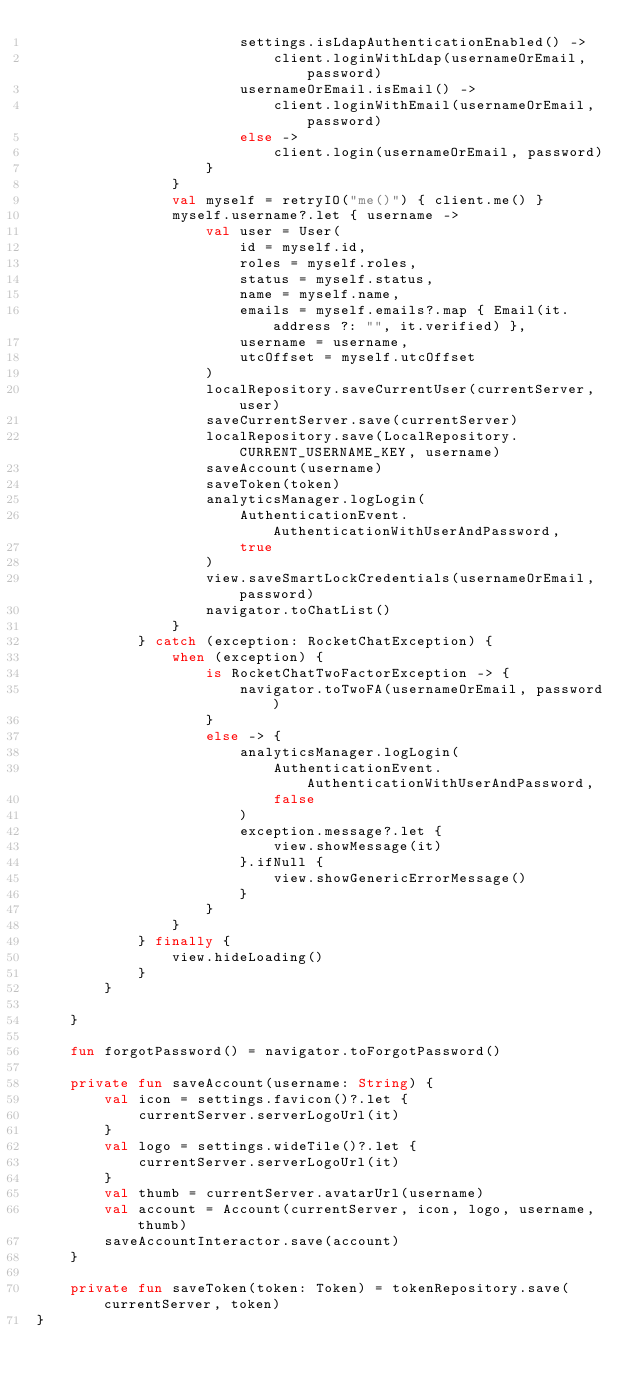<code> <loc_0><loc_0><loc_500><loc_500><_Kotlin_>                        settings.isLdapAuthenticationEnabled() ->
                            client.loginWithLdap(usernameOrEmail, password)
                        usernameOrEmail.isEmail() ->
                            client.loginWithEmail(usernameOrEmail, password)
                        else ->
                            client.login(usernameOrEmail, password)
                    }
                }
                val myself = retryIO("me()") { client.me() }
                myself.username?.let { username ->
                    val user = User(
                        id = myself.id,
                        roles = myself.roles,
                        status = myself.status,
                        name = myself.name,
                        emails = myself.emails?.map { Email(it.address ?: "", it.verified) },
                        username = username,
                        utcOffset = myself.utcOffset
                    )
                    localRepository.saveCurrentUser(currentServer, user)
                    saveCurrentServer.save(currentServer)
                    localRepository.save(LocalRepository.CURRENT_USERNAME_KEY, username)
                    saveAccount(username)
                    saveToken(token)
                    analyticsManager.logLogin(
                        AuthenticationEvent.AuthenticationWithUserAndPassword,
                        true
                    )
                    view.saveSmartLockCredentials(usernameOrEmail, password)
                    navigator.toChatList()
                }
            } catch (exception: RocketChatException) {
                when (exception) {
                    is RocketChatTwoFactorException -> {
                        navigator.toTwoFA(usernameOrEmail, password)
                    }
                    else -> {
                        analyticsManager.logLogin(
                            AuthenticationEvent.AuthenticationWithUserAndPassword,
                            false
                        )
                        exception.message?.let {
                            view.showMessage(it)
                        }.ifNull {
                            view.showGenericErrorMessage()
                        }
                    }
                }
            } finally {
                view.hideLoading()
            }
        }

    }

    fun forgotPassword() = navigator.toForgotPassword()

    private fun saveAccount(username: String) {
        val icon = settings.favicon()?.let {
            currentServer.serverLogoUrl(it)
        }
        val logo = settings.wideTile()?.let {
            currentServer.serverLogoUrl(it)
        }
        val thumb = currentServer.avatarUrl(username)
        val account = Account(currentServer, icon, logo, username, thumb)
        saveAccountInteractor.save(account)
    }

    private fun saveToken(token: Token) = tokenRepository.save(currentServer, token)
}</code> 